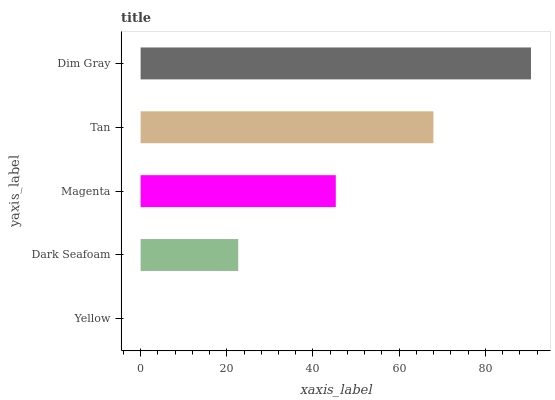Is Yellow the minimum?
Answer yes or no. Yes. Is Dim Gray the maximum?
Answer yes or no. Yes. Is Dark Seafoam the minimum?
Answer yes or no. No. Is Dark Seafoam the maximum?
Answer yes or no. No. Is Dark Seafoam greater than Yellow?
Answer yes or no. Yes. Is Yellow less than Dark Seafoam?
Answer yes or no. Yes. Is Yellow greater than Dark Seafoam?
Answer yes or no. No. Is Dark Seafoam less than Yellow?
Answer yes or no. No. Is Magenta the high median?
Answer yes or no. Yes. Is Magenta the low median?
Answer yes or no. Yes. Is Yellow the high median?
Answer yes or no. No. Is Dim Gray the low median?
Answer yes or no. No. 